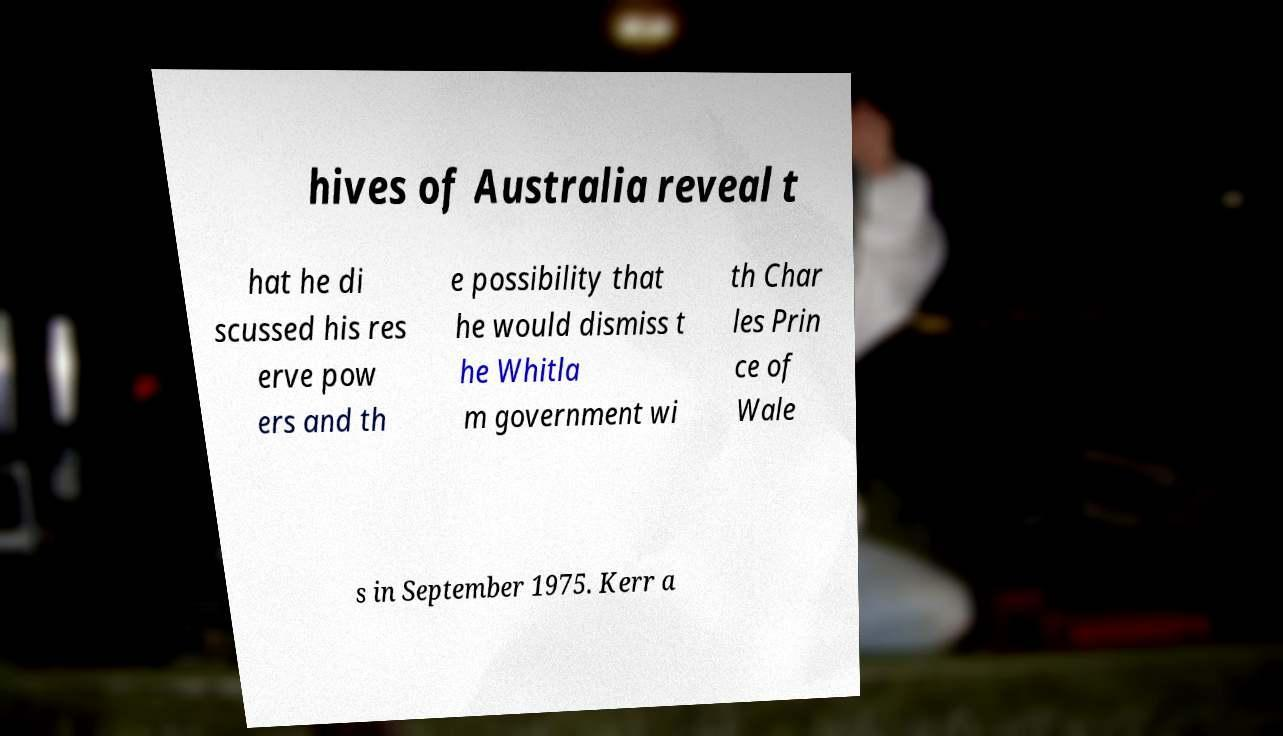Could you assist in decoding the text presented in this image and type it out clearly? hives of Australia reveal t hat he di scussed his res erve pow ers and th e possibility that he would dismiss t he Whitla m government wi th Char les Prin ce of Wale s in September 1975. Kerr a 